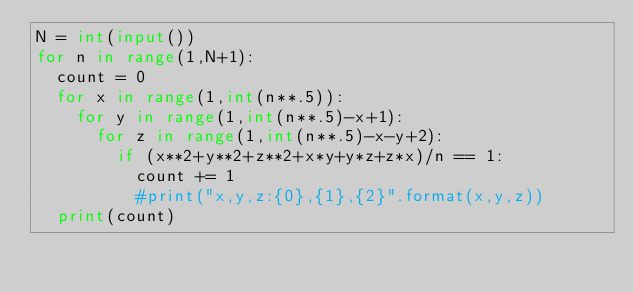<code> <loc_0><loc_0><loc_500><loc_500><_Python_>N = int(input())
for n in range(1,N+1):
  count = 0
  for x in range(1,int(n**.5)):
    for y in range(1,int(n**.5)-x+1):
      for z in range(1,int(n**.5)-x-y+2):
        if (x**2+y**2+z**2+x*y+y*z+z*x)/n == 1:
          count += 1
          #print("x,y,z:{0},{1},{2}".format(x,y,z))
  print(count)</code> 